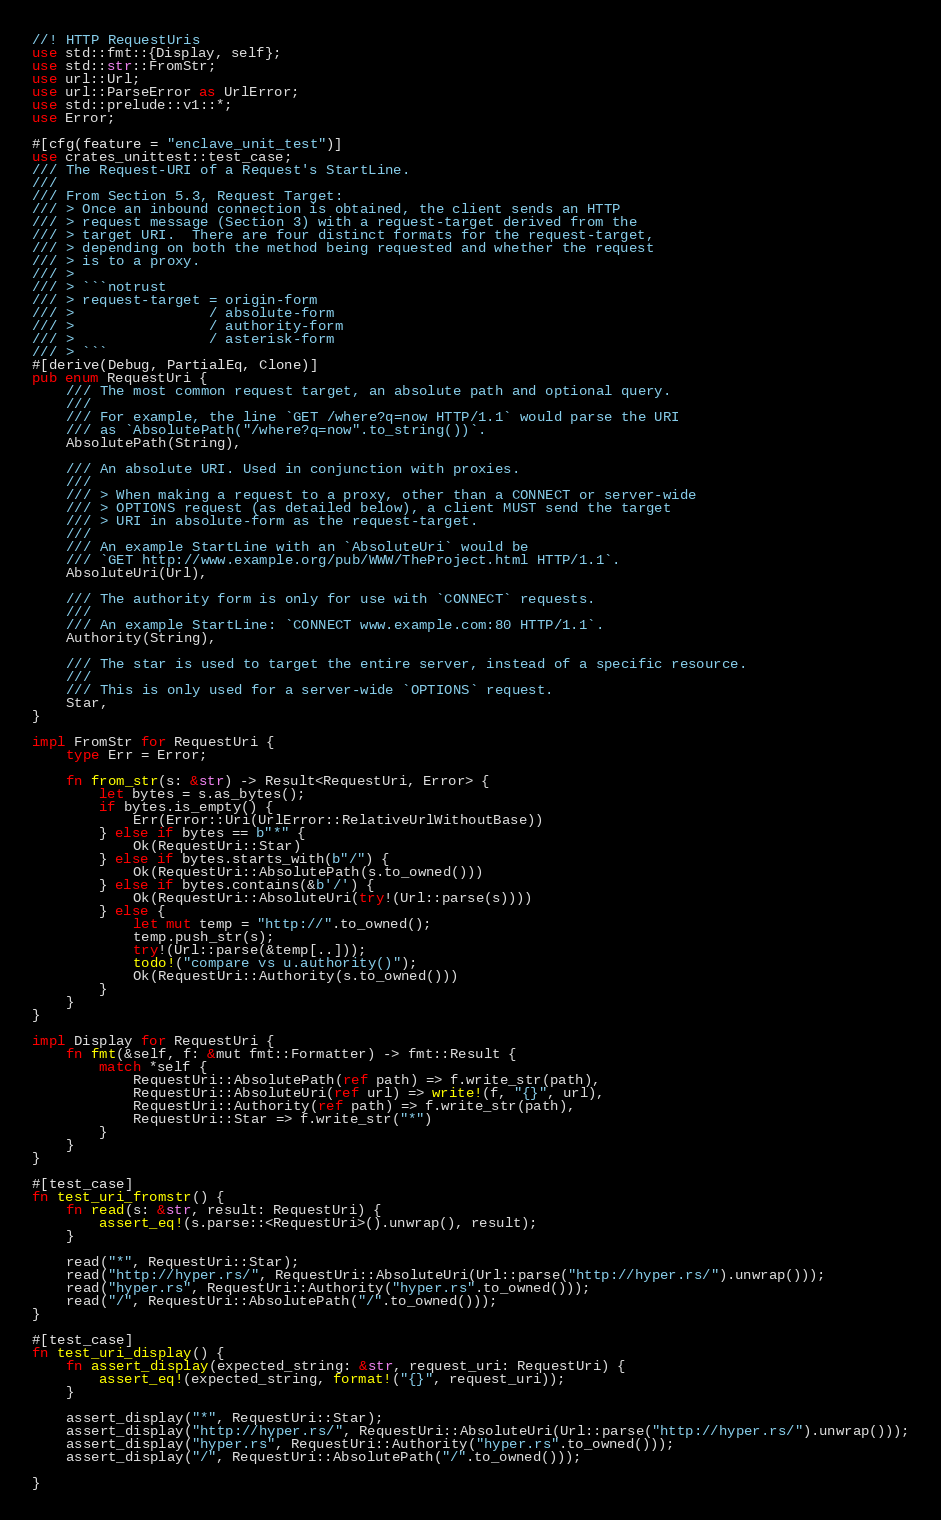Convert code to text. <code><loc_0><loc_0><loc_500><loc_500><_Rust_>//! HTTP RequestUris
use std::fmt::{Display, self};
use std::str::FromStr;
use url::Url;
use url::ParseError as UrlError;
use std::prelude::v1::*;
use Error;

#[cfg(feature = "enclave_unit_test")]
use crates_unittest::test_case;
/// The Request-URI of a Request's StartLine.
///
/// From Section 5.3, Request Target:
/// > Once an inbound connection is obtained, the client sends an HTTP
/// > request message (Section 3) with a request-target derived from the
/// > target URI.  There are four distinct formats for the request-target,
/// > depending on both the method being requested and whether the request
/// > is to a proxy.
/// >
/// > ```notrust
/// > request-target = origin-form
/// >                / absolute-form
/// >                / authority-form
/// >                / asterisk-form
/// > ```
#[derive(Debug, PartialEq, Clone)]
pub enum RequestUri {
    /// The most common request target, an absolute path and optional query.
    ///
    /// For example, the line `GET /where?q=now HTTP/1.1` would parse the URI
    /// as `AbsolutePath("/where?q=now".to_string())`.
    AbsolutePath(String),

    /// An absolute URI. Used in conjunction with proxies.
    ///
    /// > When making a request to a proxy, other than a CONNECT or server-wide
    /// > OPTIONS request (as detailed below), a client MUST send the target
    /// > URI in absolute-form as the request-target.
    ///
    /// An example StartLine with an `AbsoluteUri` would be
    /// `GET http://www.example.org/pub/WWW/TheProject.html HTTP/1.1`.
    AbsoluteUri(Url),

    /// The authority form is only for use with `CONNECT` requests.
    ///
    /// An example StartLine: `CONNECT www.example.com:80 HTTP/1.1`.
    Authority(String),

    /// The star is used to target the entire server, instead of a specific resource.
    ///
    /// This is only used for a server-wide `OPTIONS` request.
    Star,
}

impl FromStr for RequestUri {
    type Err = Error;

    fn from_str(s: &str) -> Result<RequestUri, Error> {
        let bytes = s.as_bytes();
        if bytes.is_empty() {
            Err(Error::Uri(UrlError::RelativeUrlWithoutBase))
        } else if bytes == b"*" {
            Ok(RequestUri::Star)
        } else if bytes.starts_with(b"/") {
            Ok(RequestUri::AbsolutePath(s.to_owned()))
        } else if bytes.contains(&b'/') {
            Ok(RequestUri::AbsoluteUri(try!(Url::parse(s))))
        } else {
            let mut temp = "http://".to_owned();
            temp.push_str(s);
            try!(Url::parse(&temp[..]));
            todo!("compare vs u.authority()");
            Ok(RequestUri::Authority(s.to_owned()))
        }
    }
}

impl Display for RequestUri {
    fn fmt(&self, f: &mut fmt::Formatter) -> fmt::Result {
        match *self {
            RequestUri::AbsolutePath(ref path) => f.write_str(path),
            RequestUri::AbsoluteUri(ref url) => write!(f, "{}", url),
            RequestUri::Authority(ref path) => f.write_str(path),
            RequestUri::Star => f.write_str("*")
        }
    }
}

#[test_case]
fn test_uri_fromstr() {
    fn read(s: &str, result: RequestUri) {
        assert_eq!(s.parse::<RequestUri>().unwrap(), result);
    }

    read("*", RequestUri::Star);
    read("http://hyper.rs/", RequestUri::AbsoluteUri(Url::parse("http://hyper.rs/").unwrap()));
    read("hyper.rs", RequestUri::Authority("hyper.rs".to_owned()));
    read("/", RequestUri::AbsolutePath("/".to_owned()));
}

#[test_case]
fn test_uri_display() {
    fn assert_display(expected_string: &str, request_uri: RequestUri) {
        assert_eq!(expected_string, format!("{}", request_uri));
    }

    assert_display("*", RequestUri::Star);
    assert_display("http://hyper.rs/", RequestUri::AbsoluteUri(Url::parse("http://hyper.rs/").unwrap()));
    assert_display("hyper.rs", RequestUri::Authority("hyper.rs".to_owned()));
    assert_display("/", RequestUri::AbsolutePath("/".to_owned()));

}
</code> 